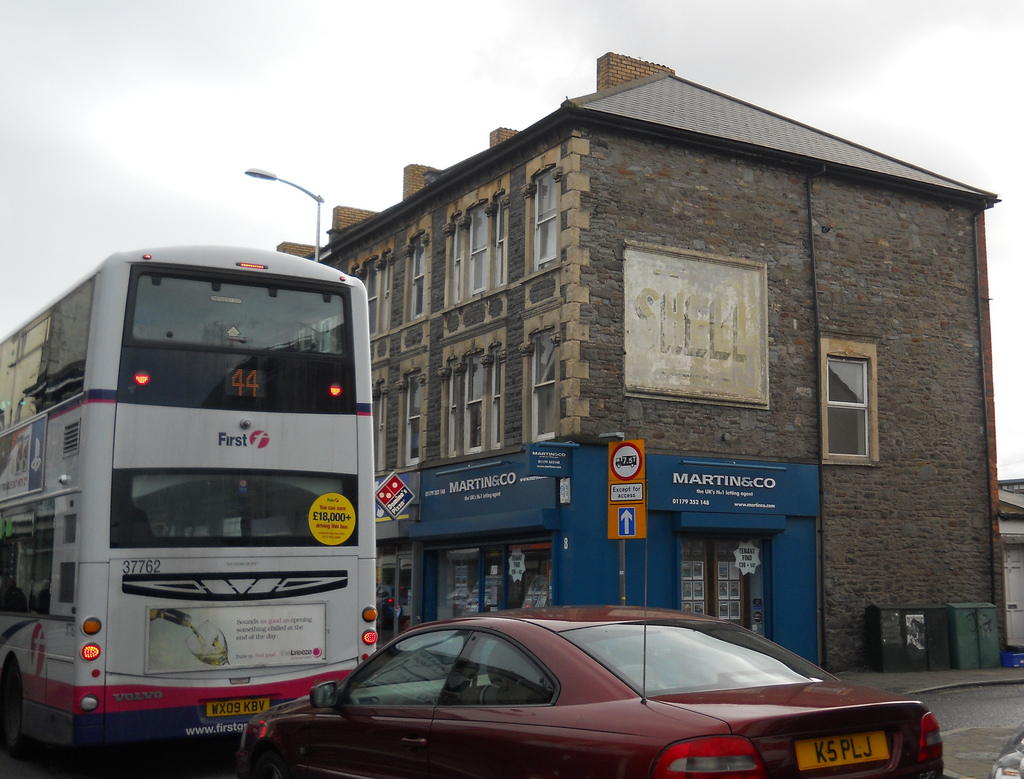Please describe the entire scene in detail. The image depicts an urban street scene. On the left side of the image, there is a white double-decker bus with a visible route number '44' at the top. The license plate of the bus reads 'WX09 KBV.' The bus belongs to the 'First' company, as indicated by the logo. In the background is a multi-story brick building with several windows, and an aged 'SHELL' sign is barely visible. The building has a business in the lower part with clear signage, likely a real estate office, and a domino's pizza sign is also present. In the foreground, there is a red sedan car with the license plate 'K5 PLJ'. Overall, it's a bustling street in front of an old yet vibrant city backdrop. What do you think the scene is like at night? At night, this scene likely transforms into something quite different. The street might be quieter with less traffic. The building's windows could be lit up, casting a warm glow on the street. Streetlights would illuminate the area, and the buses might be less frequent. The vibrant signs for businesses like Domino's Pizza and the real estate office might stand out more under artificial light, making the old 'SHELL' sign seem even more faded by contrast. The red sedan would reflect the street lights, and the storefronts would likely be closed, giving the street a more serene and contemplative atmosphere compared to the daytime hustle. Imagine if the scene was set in a different era, like the 1950s. How would it look? Transforming this scene into the 1950s, the environment would be notably different. The double-decker bus would be replaced by a vintage bus, likely in a more classical color scheme. The cars on the street would be older models with more curvaceous designs and chrome details. The building's 'SHELL' sign would appear newer and more vibrant, indicative of its prime branding era. Shops in the building might advertise different businesses, possibly local grocers or diners. The street would have fewer advertisements, and the overall aesthetic would adopt a nostalgic charm with simpler, more modest signage and store displays. The atmosphere would be bustling but with a slower pace, reflecting the lifestyle of the mid-20th century. Can you create a short story based on this scene involving the characters in the image? In a bustling corner of Bristol, Clara waited patiently by the bus stop. The large number 44 bus had just pulled in, its doors sighing open to release the day's last commuters. She watched as Mr. Thompson, the elderly florist from down the road, stepped off the bus with a small, wrapped bouquet. Clara smiled, waving at him as he headed towards his shop.

Just then, a red sedan pulled up to the curb in front of the MARTIN&CO office. Andrew, a young real estate agent fresh out of university, emerged from the car with a look of determination. He had just closed a major deal and was heading to the office to finish the paperwork. His confidence radiated, but a hint of fatigue shadowed his eyes.

Domino's signboard gleamed in the dusky evening light, hinting at a promise of a warm meal after a long day. Clara felt the vibrations of her phone, a message from her friend inviting her to dinner at the pizza place around the corner. As she typed her response, she noticed a figure emerging from the MARTIN&CO office - it was Jane, one of the senior agents, her hair perfectly coiffed, holding a stack of folders and a determined gleam in her eyes.

With a smile on her face, Clara stepped onto the bus, taking one last look at the quiet, hardworking characters in her quaint little neighborhood. It was a scene of ordinary magic, where each person's story intertwined with another’s, creating the beautiful tapestry of everyday life. 